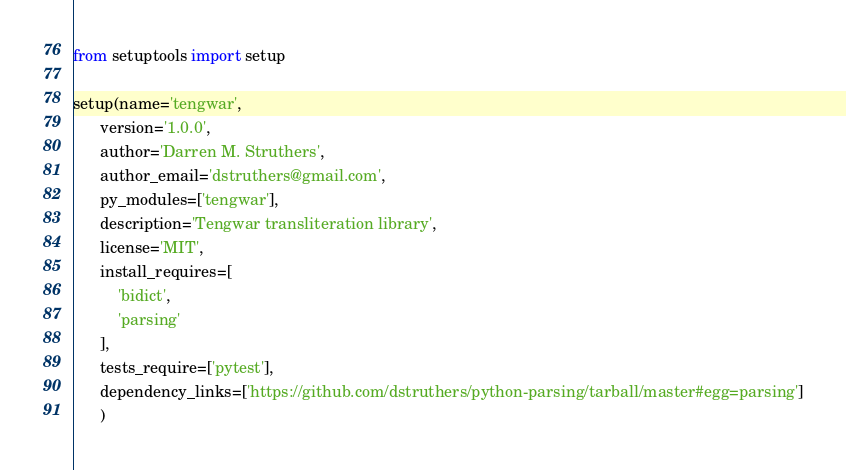Convert code to text. <code><loc_0><loc_0><loc_500><loc_500><_Python_>from setuptools import setup

setup(name='tengwar',
      version='1.0.0',
      author='Darren M. Struthers',
      author_email='dstruthers@gmail.com',
      py_modules=['tengwar'],
      description='Tengwar transliteration library',
      license='MIT',
      install_requires=[
          'bidict',
          'parsing'
      ],
      tests_require=['pytest'],
      dependency_links=['https://github.com/dstruthers/python-parsing/tarball/master#egg=parsing']
      )
</code> 